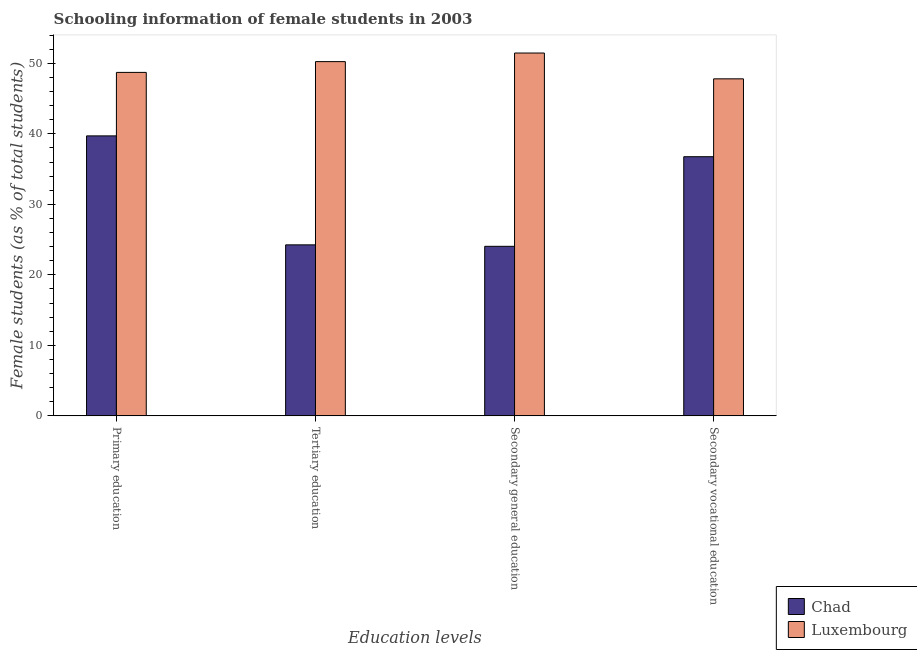How many groups of bars are there?
Offer a very short reply. 4. How many bars are there on the 2nd tick from the right?
Your response must be concise. 2. What is the label of the 1st group of bars from the left?
Your answer should be compact. Primary education. What is the percentage of female students in primary education in Chad?
Your response must be concise. 39.7. Across all countries, what is the maximum percentage of female students in primary education?
Your answer should be very brief. 48.71. Across all countries, what is the minimum percentage of female students in primary education?
Make the answer very short. 39.7. In which country was the percentage of female students in primary education maximum?
Your answer should be compact. Luxembourg. In which country was the percentage of female students in primary education minimum?
Offer a terse response. Chad. What is the total percentage of female students in secondary vocational education in the graph?
Your response must be concise. 84.54. What is the difference between the percentage of female students in primary education in Luxembourg and that in Chad?
Give a very brief answer. 9. What is the difference between the percentage of female students in primary education in Chad and the percentage of female students in secondary education in Luxembourg?
Provide a short and direct response. -11.75. What is the average percentage of female students in primary education per country?
Your response must be concise. 44.21. What is the difference between the percentage of female students in secondary vocational education and percentage of female students in tertiary education in Chad?
Your answer should be very brief. 12.5. In how many countries, is the percentage of female students in secondary education greater than 28 %?
Give a very brief answer. 1. What is the ratio of the percentage of female students in secondary education in Luxembourg to that in Chad?
Offer a very short reply. 2.14. Is the percentage of female students in secondary education in Luxembourg less than that in Chad?
Ensure brevity in your answer.  No. What is the difference between the highest and the second highest percentage of female students in primary education?
Your answer should be compact. 9. What is the difference between the highest and the lowest percentage of female students in secondary education?
Offer a very short reply. 27.41. In how many countries, is the percentage of female students in secondary education greater than the average percentage of female students in secondary education taken over all countries?
Offer a very short reply. 1. Is the sum of the percentage of female students in secondary education in Chad and Luxembourg greater than the maximum percentage of female students in secondary vocational education across all countries?
Offer a terse response. Yes. Is it the case that in every country, the sum of the percentage of female students in secondary vocational education and percentage of female students in primary education is greater than the sum of percentage of female students in tertiary education and percentage of female students in secondary education?
Ensure brevity in your answer.  No. What does the 2nd bar from the left in Secondary general education represents?
Keep it short and to the point. Luxembourg. What does the 1st bar from the right in Primary education represents?
Offer a very short reply. Luxembourg. Is it the case that in every country, the sum of the percentage of female students in primary education and percentage of female students in tertiary education is greater than the percentage of female students in secondary education?
Your answer should be compact. Yes. What is the difference between two consecutive major ticks on the Y-axis?
Provide a short and direct response. 10. Does the graph contain any zero values?
Your answer should be very brief. No. Does the graph contain grids?
Provide a short and direct response. No. What is the title of the graph?
Provide a short and direct response. Schooling information of female students in 2003. What is the label or title of the X-axis?
Make the answer very short. Education levels. What is the label or title of the Y-axis?
Your answer should be compact. Female students (as % of total students). What is the Female students (as % of total students) of Chad in Primary education?
Your answer should be compact. 39.7. What is the Female students (as % of total students) in Luxembourg in Primary education?
Your response must be concise. 48.71. What is the Female students (as % of total students) of Chad in Tertiary education?
Your response must be concise. 24.25. What is the Female students (as % of total students) of Luxembourg in Tertiary education?
Keep it short and to the point. 50.24. What is the Female students (as % of total students) in Chad in Secondary general education?
Ensure brevity in your answer.  24.04. What is the Female students (as % of total students) of Luxembourg in Secondary general education?
Your answer should be very brief. 51.46. What is the Female students (as % of total students) of Chad in Secondary vocational education?
Provide a short and direct response. 36.75. What is the Female students (as % of total students) in Luxembourg in Secondary vocational education?
Ensure brevity in your answer.  47.79. Across all Education levels, what is the maximum Female students (as % of total students) of Chad?
Give a very brief answer. 39.7. Across all Education levels, what is the maximum Female students (as % of total students) in Luxembourg?
Provide a short and direct response. 51.46. Across all Education levels, what is the minimum Female students (as % of total students) in Chad?
Offer a very short reply. 24.04. Across all Education levels, what is the minimum Female students (as % of total students) in Luxembourg?
Ensure brevity in your answer.  47.79. What is the total Female students (as % of total students) in Chad in the graph?
Ensure brevity in your answer.  124.75. What is the total Female students (as % of total students) of Luxembourg in the graph?
Give a very brief answer. 198.19. What is the difference between the Female students (as % of total students) of Chad in Primary education and that in Tertiary education?
Provide a short and direct response. 15.45. What is the difference between the Female students (as % of total students) in Luxembourg in Primary education and that in Tertiary education?
Offer a very short reply. -1.53. What is the difference between the Female students (as % of total students) of Chad in Primary education and that in Secondary general education?
Give a very brief answer. 15.66. What is the difference between the Female students (as % of total students) in Luxembourg in Primary education and that in Secondary general education?
Ensure brevity in your answer.  -2.75. What is the difference between the Female students (as % of total students) of Chad in Primary education and that in Secondary vocational education?
Make the answer very short. 2.95. What is the difference between the Female students (as % of total students) of Luxembourg in Primary education and that in Secondary vocational education?
Provide a succinct answer. 0.91. What is the difference between the Female students (as % of total students) in Chad in Tertiary education and that in Secondary general education?
Provide a short and direct response. 0.21. What is the difference between the Female students (as % of total students) in Luxembourg in Tertiary education and that in Secondary general education?
Keep it short and to the point. -1.22. What is the difference between the Female students (as % of total students) in Chad in Tertiary education and that in Secondary vocational education?
Offer a very short reply. -12.5. What is the difference between the Female students (as % of total students) of Luxembourg in Tertiary education and that in Secondary vocational education?
Offer a terse response. 2.44. What is the difference between the Female students (as % of total students) in Chad in Secondary general education and that in Secondary vocational education?
Offer a very short reply. -12.71. What is the difference between the Female students (as % of total students) in Luxembourg in Secondary general education and that in Secondary vocational education?
Offer a very short reply. 3.66. What is the difference between the Female students (as % of total students) of Chad in Primary education and the Female students (as % of total students) of Luxembourg in Tertiary education?
Provide a succinct answer. -10.53. What is the difference between the Female students (as % of total students) of Chad in Primary education and the Female students (as % of total students) of Luxembourg in Secondary general education?
Your response must be concise. -11.75. What is the difference between the Female students (as % of total students) of Chad in Primary education and the Female students (as % of total students) of Luxembourg in Secondary vocational education?
Offer a terse response. -8.09. What is the difference between the Female students (as % of total students) of Chad in Tertiary education and the Female students (as % of total students) of Luxembourg in Secondary general education?
Offer a very short reply. -27.2. What is the difference between the Female students (as % of total students) in Chad in Tertiary education and the Female students (as % of total students) in Luxembourg in Secondary vocational education?
Keep it short and to the point. -23.54. What is the difference between the Female students (as % of total students) of Chad in Secondary general education and the Female students (as % of total students) of Luxembourg in Secondary vocational education?
Your answer should be compact. -23.75. What is the average Female students (as % of total students) in Chad per Education levels?
Provide a succinct answer. 31.19. What is the average Female students (as % of total students) of Luxembourg per Education levels?
Give a very brief answer. 49.55. What is the difference between the Female students (as % of total students) in Chad and Female students (as % of total students) in Luxembourg in Primary education?
Your answer should be compact. -9. What is the difference between the Female students (as % of total students) in Chad and Female students (as % of total students) in Luxembourg in Tertiary education?
Ensure brevity in your answer.  -25.98. What is the difference between the Female students (as % of total students) of Chad and Female students (as % of total students) of Luxembourg in Secondary general education?
Your answer should be very brief. -27.41. What is the difference between the Female students (as % of total students) of Chad and Female students (as % of total students) of Luxembourg in Secondary vocational education?
Provide a succinct answer. -11.04. What is the ratio of the Female students (as % of total students) of Chad in Primary education to that in Tertiary education?
Ensure brevity in your answer.  1.64. What is the ratio of the Female students (as % of total students) of Luxembourg in Primary education to that in Tertiary education?
Your answer should be very brief. 0.97. What is the ratio of the Female students (as % of total students) of Chad in Primary education to that in Secondary general education?
Your answer should be very brief. 1.65. What is the ratio of the Female students (as % of total students) in Luxembourg in Primary education to that in Secondary general education?
Give a very brief answer. 0.95. What is the ratio of the Female students (as % of total students) in Chad in Primary education to that in Secondary vocational education?
Make the answer very short. 1.08. What is the ratio of the Female students (as % of total students) of Luxembourg in Primary education to that in Secondary vocational education?
Provide a short and direct response. 1.02. What is the ratio of the Female students (as % of total students) in Chad in Tertiary education to that in Secondary general education?
Ensure brevity in your answer.  1.01. What is the ratio of the Female students (as % of total students) in Luxembourg in Tertiary education to that in Secondary general education?
Provide a short and direct response. 0.98. What is the ratio of the Female students (as % of total students) in Chad in Tertiary education to that in Secondary vocational education?
Provide a succinct answer. 0.66. What is the ratio of the Female students (as % of total students) of Luxembourg in Tertiary education to that in Secondary vocational education?
Give a very brief answer. 1.05. What is the ratio of the Female students (as % of total students) in Chad in Secondary general education to that in Secondary vocational education?
Make the answer very short. 0.65. What is the ratio of the Female students (as % of total students) in Luxembourg in Secondary general education to that in Secondary vocational education?
Give a very brief answer. 1.08. What is the difference between the highest and the second highest Female students (as % of total students) of Chad?
Keep it short and to the point. 2.95. What is the difference between the highest and the second highest Female students (as % of total students) in Luxembourg?
Provide a short and direct response. 1.22. What is the difference between the highest and the lowest Female students (as % of total students) in Chad?
Offer a terse response. 15.66. What is the difference between the highest and the lowest Female students (as % of total students) in Luxembourg?
Your answer should be compact. 3.66. 